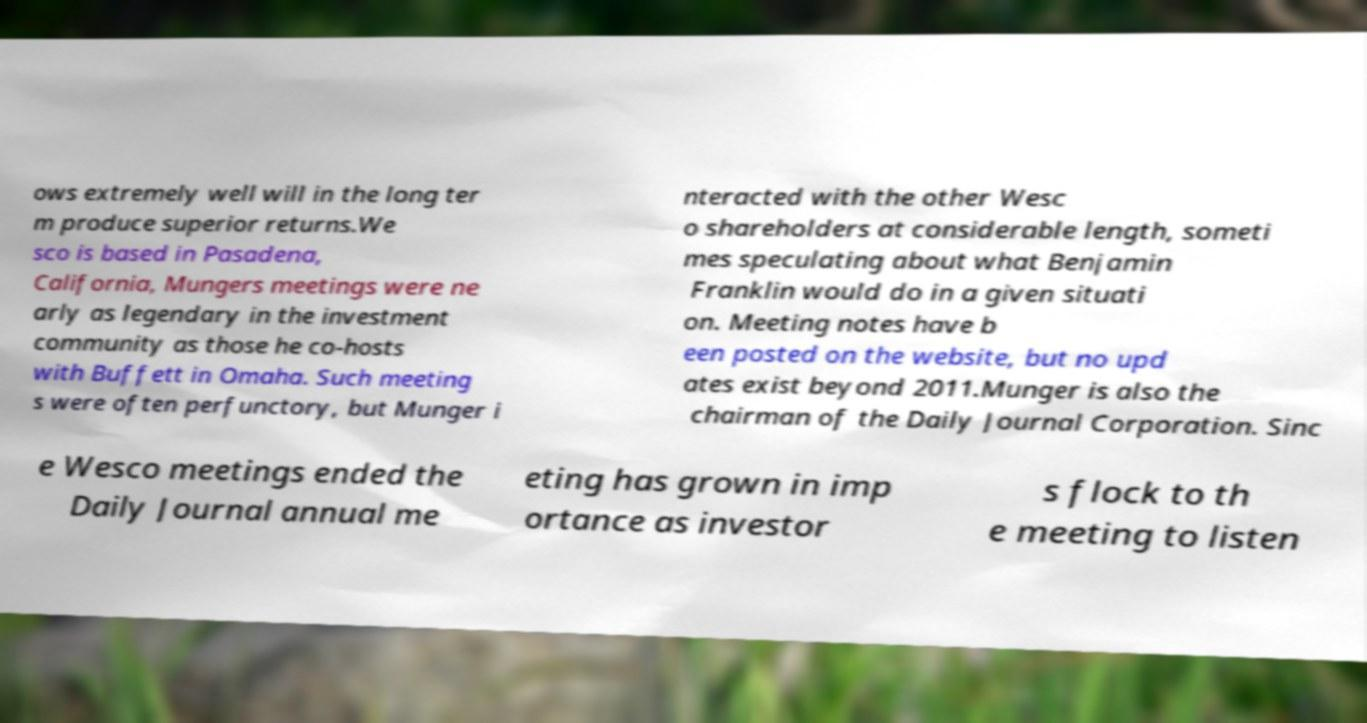Please identify and transcribe the text found in this image. ows extremely well will in the long ter m produce superior returns.We sco is based in Pasadena, California, Mungers meetings were ne arly as legendary in the investment community as those he co-hosts with Buffett in Omaha. Such meeting s were often perfunctory, but Munger i nteracted with the other Wesc o shareholders at considerable length, someti mes speculating about what Benjamin Franklin would do in a given situati on. Meeting notes have b een posted on the website, but no upd ates exist beyond 2011.Munger is also the chairman of the Daily Journal Corporation. Sinc e Wesco meetings ended the Daily Journal annual me eting has grown in imp ortance as investor s flock to th e meeting to listen 